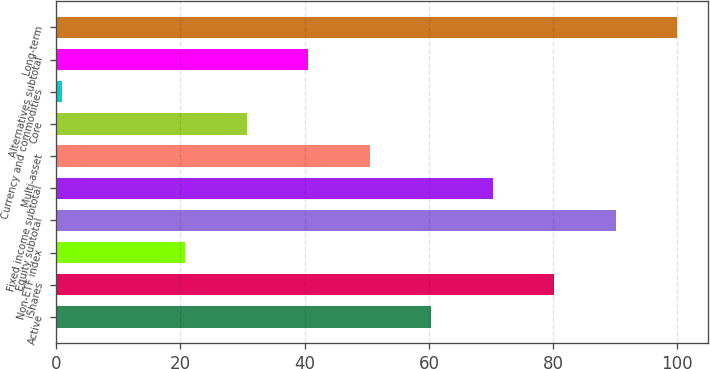<chart> <loc_0><loc_0><loc_500><loc_500><bar_chart><fcel>Active<fcel>iShares<fcel>Non-ETF index<fcel>Equity subtotal<fcel>Fixed income subtotal<fcel>Multi-asset<fcel>Core<fcel>Currency and commodities<fcel>Alternatives subtotal<fcel>Long-term<nl><fcel>60.4<fcel>80.2<fcel>20.8<fcel>90.1<fcel>70.3<fcel>50.5<fcel>30.7<fcel>1<fcel>40.6<fcel>100<nl></chart> 